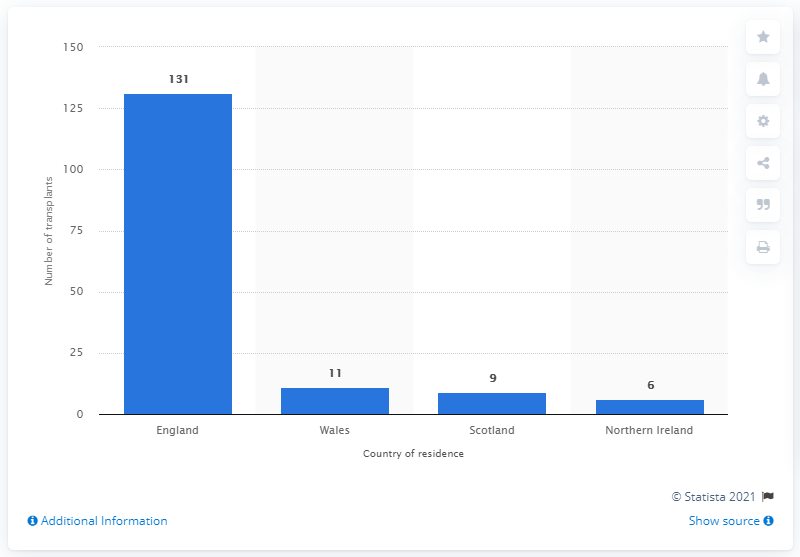List a handful of essential elements in this visual. In the year 2019/20, 131 out of the total 159 lung transplant procedures conducted in the United Kingdom were performed on patients living in England. 